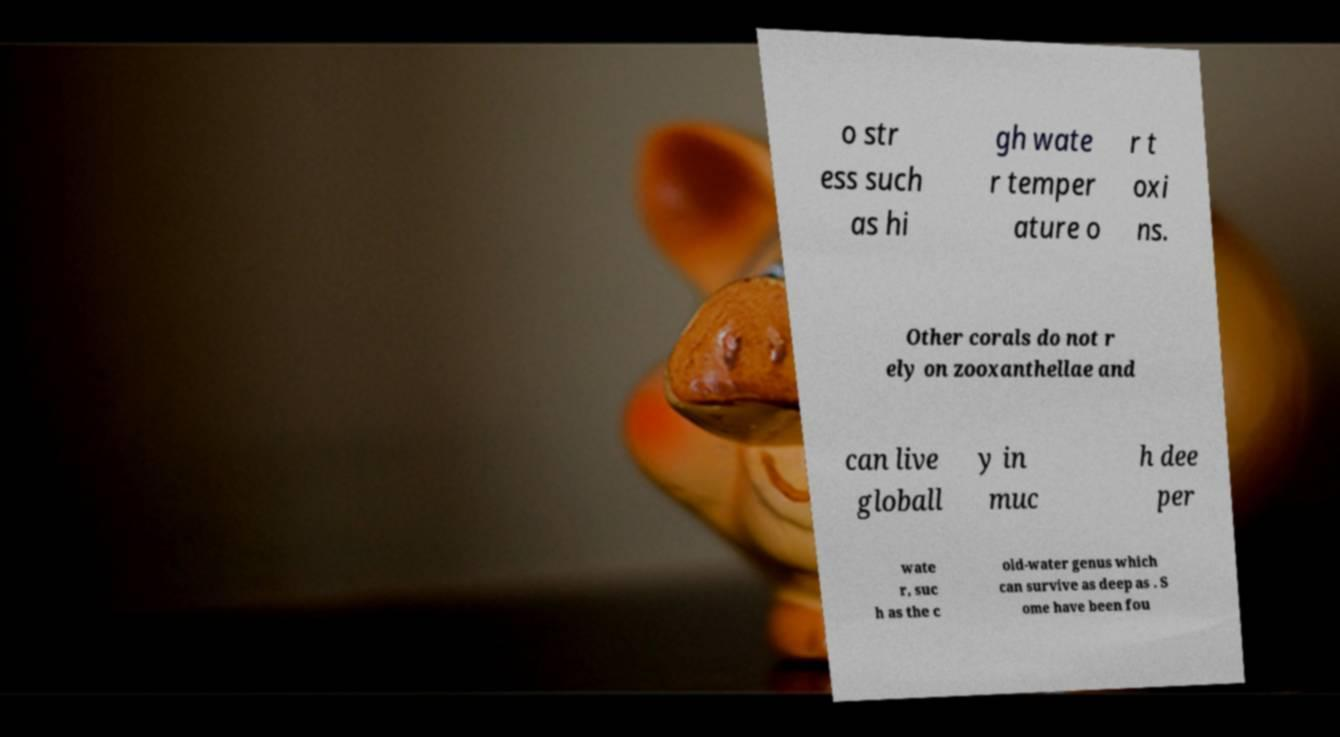For documentation purposes, I need the text within this image transcribed. Could you provide that? o str ess such as hi gh wate r temper ature o r t oxi ns. Other corals do not r ely on zooxanthellae and can live globall y in muc h dee per wate r, suc h as the c old-water genus which can survive as deep as . S ome have been fou 